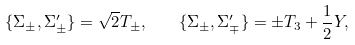Convert formula to latex. <formula><loc_0><loc_0><loc_500><loc_500>\{ \Sigma _ { \pm } , \Sigma ^ { \prime } _ { \pm } \} = \sqrt { 2 } T _ { \pm } , \quad \{ \Sigma _ { \pm } , \Sigma ^ { \prime } _ { \mp } \} = \pm T _ { 3 } + \frac { 1 } { 2 } Y ,</formula> 